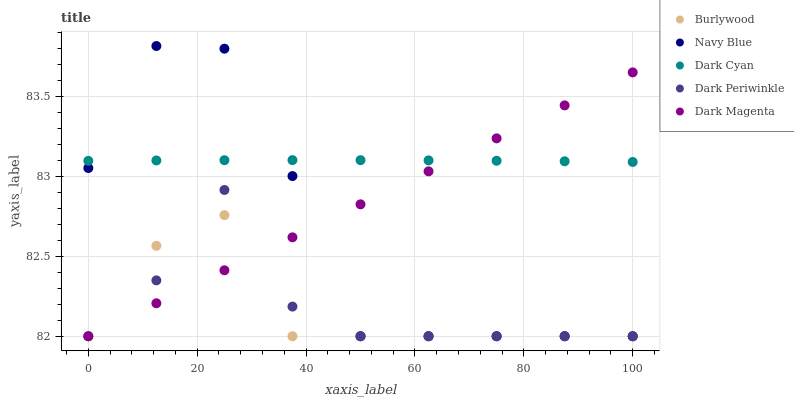Does Burlywood have the minimum area under the curve?
Answer yes or no. Yes. Does Dark Cyan have the maximum area under the curve?
Answer yes or no. Yes. Does Navy Blue have the minimum area under the curve?
Answer yes or no. No. Does Navy Blue have the maximum area under the curve?
Answer yes or no. No. Is Dark Magenta the smoothest?
Answer yes or no. Yes. Is Navy Blue the roughest?
Answer yes or no. Yes. Is Dark Cyan the smoothest?
Answer yes or no. No. Is Dark Cyan the roughest?
Answer yes or no. No. Does Burlywood have the lowest value?
Answer yes or no. Yes. Does Dark Cyan have the lowest value?
Answer yes or no. No. Does Navy Blue have the highest value?
Answer yes or no. Yes. Does Dark Cyan have the highest value?
Answer yes or no. No. Is Dark Periwinkle less than Dark Cyan?
Answer yes or no. Yes. Is Dark Cyan greater than Burlywood?
Answer yes or no. Yes. Does Dark Periwinkle intersect Navy Blue?
Answer yes or no. Yes. Is Dark Periwinkle less than Navy Blue?
Answer yes or no. No. Is Dark Periwinkle greater than Navy Blue?
Answer yes or no. No. Does Dark Periwinkle intersect Dark Cyan?
Answer yes or no. No. 